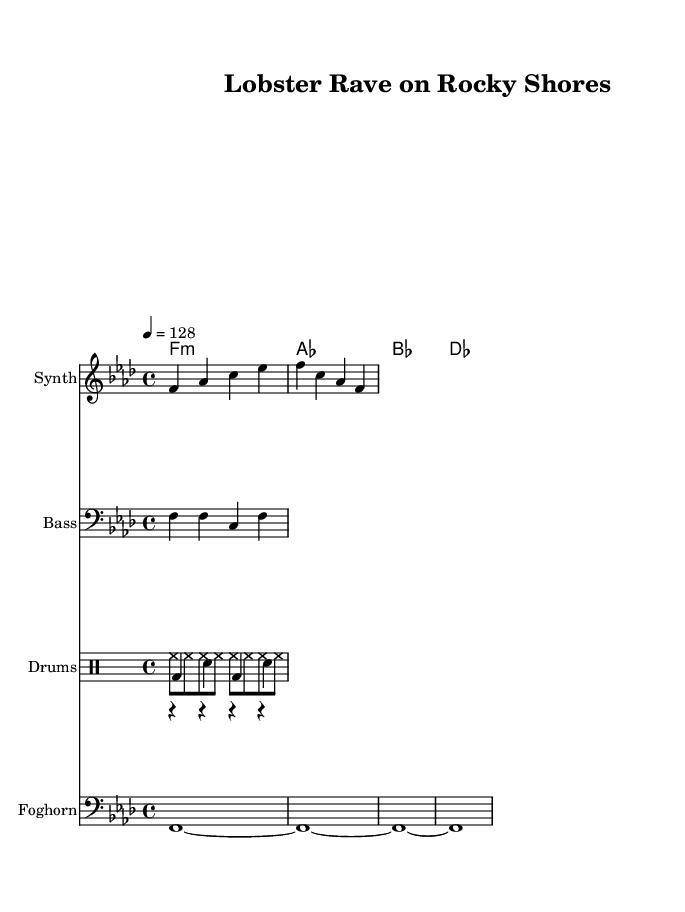What is the key signature of this music? The key signature indicates that there are four flats, which corresponds to F minor.
Answer: F minor What is the time signature of the piece? The time signature is given as 4/4, meaning there are four beats in each measure.
Answer: 4/4 What tempo marking is indicated for this piece? The tempo is marked as 128 beats per minute, telling musicians how fast to play.
Answer: 128 How many measures are included in the melody? The melody is composed of two measures, indicated by the bar lines separating the notes.
Answer: Two measures What types of drums are used in this composition? The composition includes kick, snare, and hi-hat drums, which create the essential rhythm in dance music.
Answer: Kick, snare, hi-hat What is the first chord in the harmony section? The first chord is an F minor chord as indicated by the symbol 'f1:m' at the beginning of the harmony line.
Answer: F minor Why is the foghorn used in this dance music? The foghorn serves a thematic purpose, invoking the coastal lifestyle and maritime culture of Maine, while also adding a unique sound layer to the piece.
Answer: To invoke coastal lifestyle 